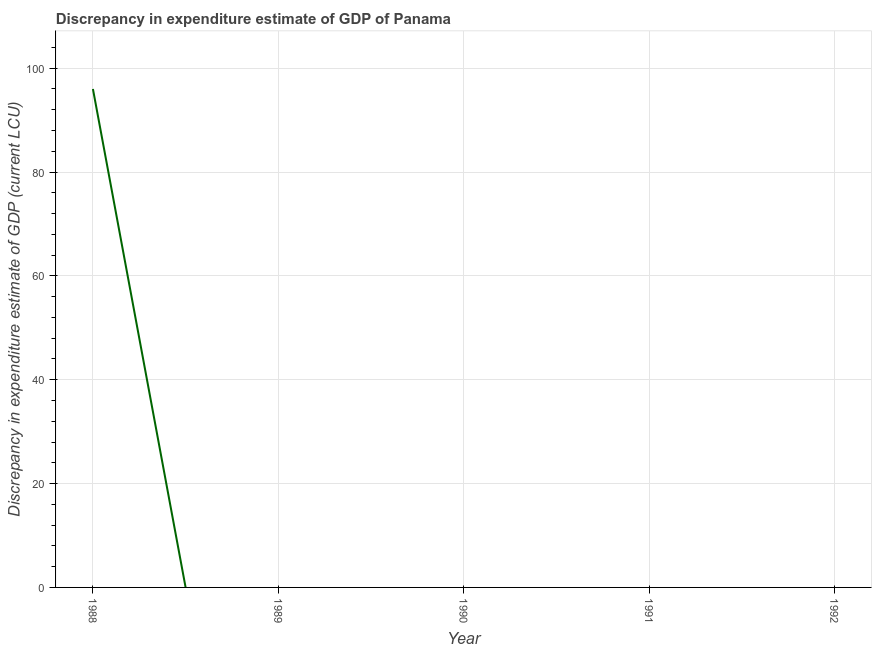Across all years, what is the maximum discrepancy in expenditure estimate of gdp?
Give a very brief answer. 96. Across all years, what is the minimum discrepancy in expenditure estimate of gdp?
Your answer should be compact. 0. What is the sum of the discrepancy in expenditure estimate of gdp?
Ensure brevity in your answer.  96. What is the average discrepancy in expenditure estimate of gdp per year?
Your response must be concise. 19.2. In how many years, is the discrepancy in expenditure estimate of gdp greater than 92 LCU?
Make the answer very short. 1. What is the difference between the highest and the lowest discrepancy in expenditure estimate of gdp?
Make the answer very short. 96. In how many years, is the discrepancy in expenditure estimate of gdp greater than the average discrepancy in expenditure estimate of gdp taken over all years?
Provide a short and direct response. 1. Does the discrepancy in expenditure estimate of gdp monotonically increase over the years?
Your answer should be very brief. No. How many years are there in the graph?
Provide a short and direct response. 5. What is the title of the graph?
Make the answer very short. Discrepancy in expenditure estimate of GDP of Panama. What is the label or title of the Y-axis?
Offer a very short reply. Discrepancy in expenditure estimate of GDP (current LCU). What is the Discrepancy in expenditure estimate of GDP (current LCU) in 1988?
Give a very brief answer. 96. What is the Discrepancy in expenditure estimate of GDP (current LCU) in 1990?
Give a very brief answer. 0. What is the Discrepancy in expenditure estimate of GDP (current LCU) of 1991?
Offer a very short reply. 0. 